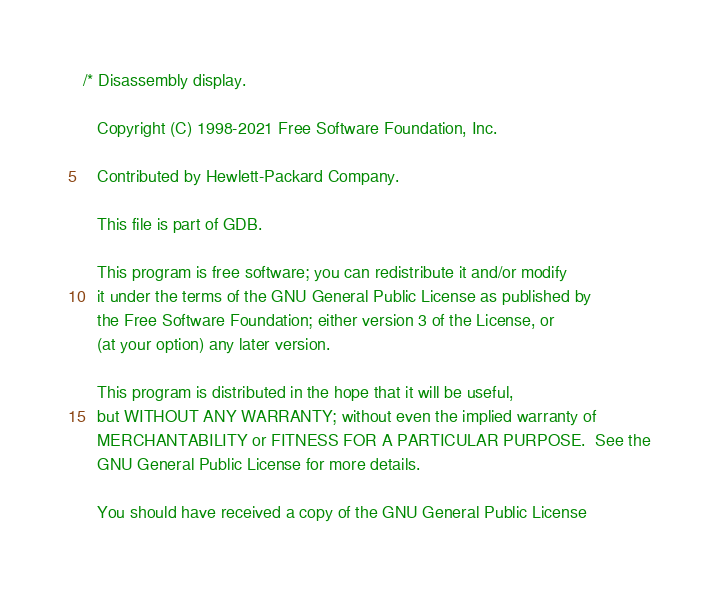<code> <loc_0><loc_0><loc_500><loc_500><_C_>/* Disassembly display.

   Copyright (C) 1998-2021 Free Software Foundation, Inc.
   
   Contributed by Hewlett-Packard Company.

   This file is part of GDB.

   This program is free software; you can redistribute it and/or modify
   it under the terms of the GNU General Public License as published by
   the Free Software Foundation; either version 3 of the License, or
   (at your option) any later version.

   This program is distributed in the hope that it will be useful,
   but WITHOUT ANY WARRANTY; without even the implied warranty of
   MERCHANTABILITY or FITNESS FOR A PARTICULAR PURPOSE.  See the
   GNU General Public License for more details.

   You should have received a copy of the GNU General Public License</code> 